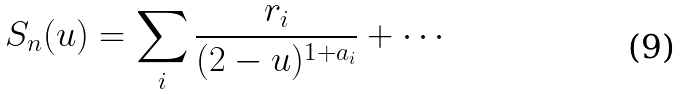Convert formula to latex. <formula><loc_0><loc_0><loc_500><loc_500>S _ { n } ( u ) = \sum _ { i } \frac { r _ { i } } { ( 2 - u ) ^ { 1 + a _ { i } } } + \cdots</formula> 